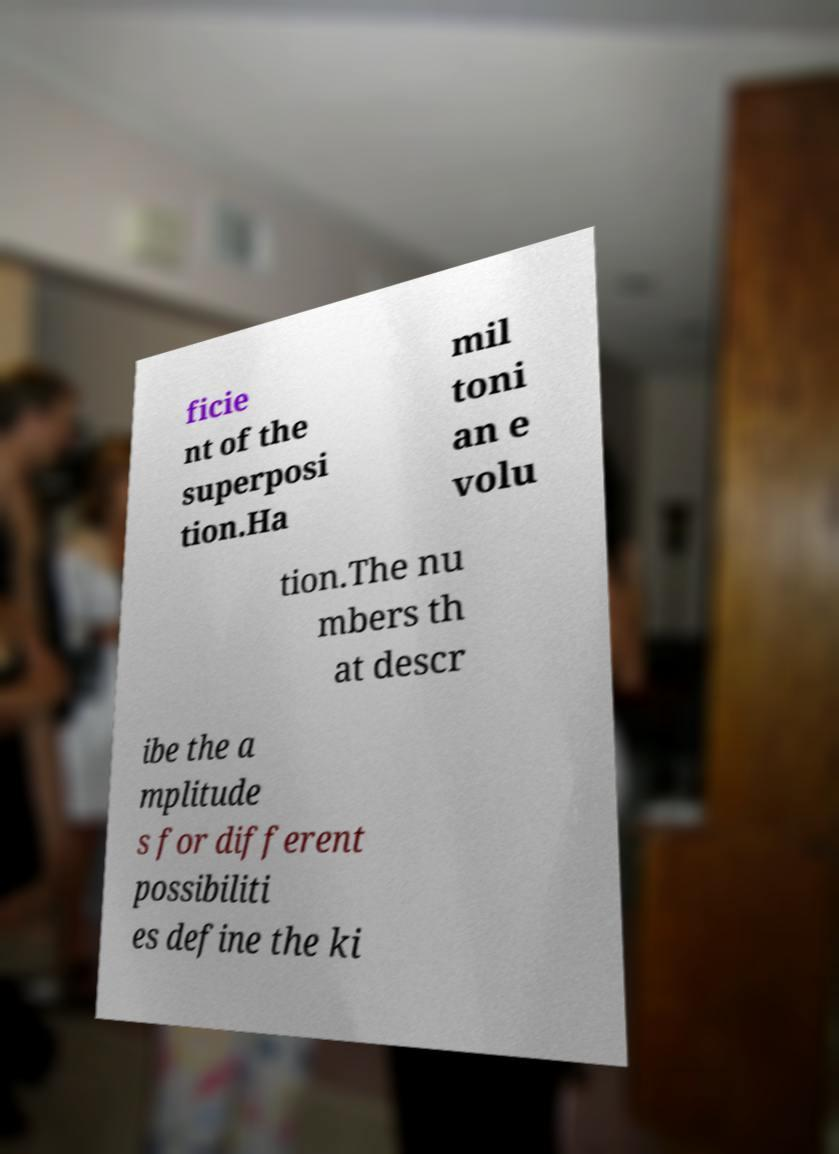What messages or text are displayed in this image? I need them in a readable, typed format. ficie nt of the superposi tion.Ha mil toni an e volu tion.The nu mbers th at descr ibe the a mplitude s for different possibiliti es define the ki 